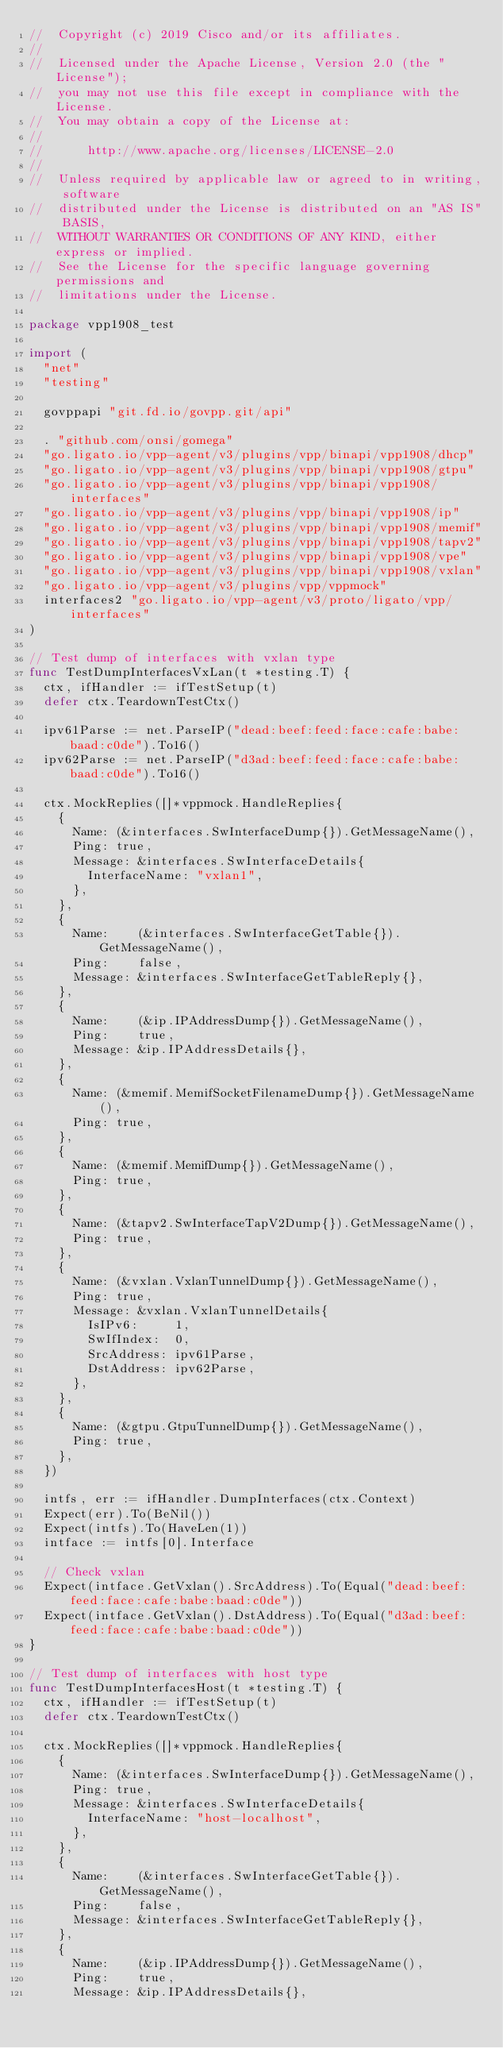<code> <loc_0><loc_0><loc_500><loc_500><_Go_>//  Copyright (c) 2019 Cisco and/or its affiliates.
//
//  Licensed under the Apache License, Version 2.0 (the "License");
//  you may not use this file except in compliance with the License.
//  You may obtain a copy of the License at:
//
//      http://www.apache.org/licenses/LICENSE-2.0
//
//  Unless required by applicable law or agreed to in writing, software
//  distributed under the License is distributed on an "AS IS" BASIS,
//  WITHOUT WARRANTIES OR CONDITIONS OF ANY KIND, either express or implied.
//  See the License for the specific language governing permissions and
//  limitations under the License.

package vpp1908_test

import (
	"net"
	"testing"

	govppapi "git.fd.io/govpp.git/api"

	. "github.com/onsi/gomega"
	"go.ligato.io/vpp-agent/v3/plugins/vpp/binapi/vpp1908/dhcp"
	"go.ligato.io/vpp-agent/v3/plugins/vpp/binapi/vpp1908/gtpu"
	"go.ligato.io/vpp-agent/v3/plugins/vpp/binapi/vpp1908/interfaces"
	"go.ligato.io/vpp-agent/v3/plugins/vpp/binapi/vpp1908/ip"
	"go.ligato.io/vpp-agent/v3/plugins/vpp/binapi/vpp1908/memif"
	"go.ligato.io/vpp-agent/v3/plugins/vpp/binapi/vpp1908/tapv2"
	"go.ligato.io/vpp-agent/v3/plugins/vpp/binapi/vpp1908/vpe"
	"go.ligato.io/vpp-agent/v3/plugins/vpp/binapi/vpp1908/vxlan"
	"go.ligato.io/vpp-agent/v3/plugins/vpp/vppmock"
	interfaces2 "go.ligato.io/vpp-agent/v3/proto/ligato/vpp/interfaces"
)

// Test dump of interfaces with vxlan type
func TestDumpInterfacesVxLan(t *testing.T) {
	ctx, ifHandler := ifTestSetup(t)
	defer ctx.TeardownTestCtx()

	ipv61Parse := net.ParseIP("dead:beef:feed:face:cafe:babe:baad:c0de").To16()
	ipv62Parse := net.ParseIP("d3ad:beef:feed:face:cafe:babe:baad:c0de").To16()

	ctx.MockReplies([]*vppmock.HandleReplies{
		{
			Name: (&interfaces.SwInterfaceDump{}).GetMessageName(),
			Ping: true,
			Message: &interfaces.SwInterfaceDetails{
				InterfaceName: "vxlan1",
			},
		},
		{
			Name:    (&interfaces.SwInterfaceGetTable{}).GetMessageName(),
			Ping:    false,
			Message: &interfaces.SwInterfaceGetTableReply{},
		},
		{
			Name:    (&ip.IPAddressDump{}).GetMessageName(),
			Ping:    true,
			Message: &ip.IPAddressDetails{},
		},
		{
			Name: (&memif.MemifSocketFilenameDump{}).GetMessageName(),
			Ping: true,
		},
		{
			Name: (&memif.MemifDump{}).GetMessageName(),
			Ping: true,
		},
		{
			Name: (&tapv2.SwInterfaceTapV2Dump{}).GetMessageName(),
			Ping: true,
		},
		{
			Name: (&vxlan.VxlanTunnelDump{}).GetMessageName(),
			Ping: true,
			Message: &vxlan.VxlanTunnelDetails{
				IsIPv6:     1,
				SwIfIndex:  0,
				SrcAddress: ipv61Parse,
				DstAddress: ipv62Parse,
			},
		},
		{
			Name: (&gtpu.GtpuTunnelDump{}).GetMessageName(),
			Ping: true,
		},
	})

	intfs, err := ifHandler.DumpInterfaces(ctx.Context)
	Expect(err).To(BeNil())
	Expect(intfs).To(HaveLen(1))
	intface := intfs[0].Interface

	// Check vxlan
	Expect(intface.GetVxlan().SrcAddress).To(Equal("dead:beef:feed:face:cafe:babe:baad:c0de"))
	Expect(intface.GetVxlan().DstAddress).To(Equal("d3ad:beef:feed:face:cafe:babe:baad:c0de"))
}

// Test dump of interfaces with host type
func TestDumpInterfacesHost(t *testing.T) {
	ctx, ifHandler := ifTestSetup(t)
	defer ctx.TeardownTestCtx()

	ctx.MockReplies([]*vppmock.HandleReplies{
		{
			Name: (&interfaces.SwInterfaceDump{}).GetMessageName(),
			Ping: true,
			Message: &interfaces.SwInterfaceDetails{
				InterfaceName: "host-localhost",
			},
		},
		{
			Name:    (&interfaces.SwInterfaceGetTable{}).GetMessageName(),
			Ping:    false,
			Message: &interfaces.SwInterfaceGetTableReply{},
		},
		{
			Name:    (&ip.IPAddressDump{}).GetMessageName(),
			Ping:    true,
			Message: &ip.IPAddressDetails{},</code> 